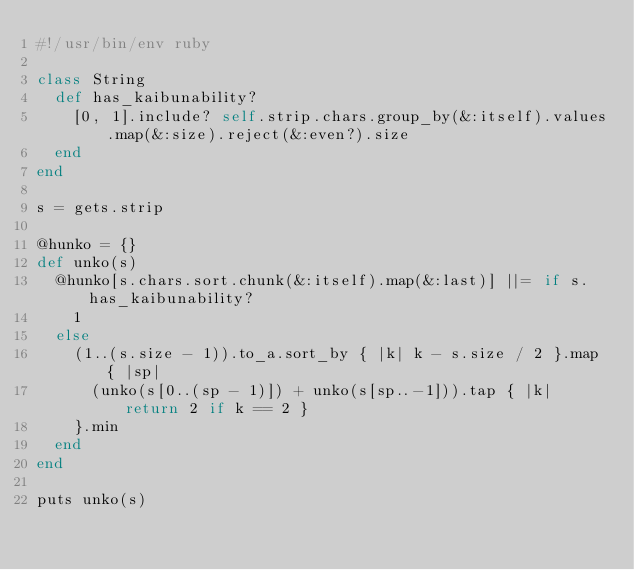<code> <loc_0><loc_0><loc_500><loc_500><_Ruby_>#!/usr/bin/env ruby

class String
  def has_kaibunability?
    [0, 1].include? self.strip.chars.group_by(&:itself).values.map(&:size).reject(&:even?).size
  end
end

s = gets.strip

@hunko = {}
def unko(s)
  @hunko[s.chars.sort.chunk(&:itself).map(&:last)] ||= if s.has_kaibunability?
    1
  else
    (1..(s.size - 1)).to_a.sort_by { |k| k - s.size / 2 }.map { |sp|
      (unko(s[0..(sp - 1)]) + unko(s[sp..-1])).tap { |k| return 2 if k == 2 }
    }.min
  end
end

puts unko(s)
</code> 